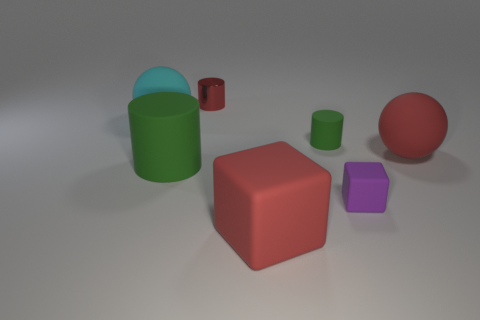Does the small shiny thing have the same color as the big block?
Your answer should be compact. Yes. What number of red things are made of the same material as the large red block?
Offer a terse response. 1. Are there any blocks left of the purple matte thing?
Provide a short and direct response. Yes. The matte ball that is the same size as the cyan matte thing is what color?
Your response must be concise. Red. What number of objects are either small purple blocks that are right of the big green cylinder or green things?
Provide a short and direct response. 3. What size is the object that is both on the right side of the small rubber cylinder and behind the purple object?
Offer a terse response. Large. There is a thing that is the same color as the big cylinder; what size is it?
Provide a short and direct response. Small. How many other things are the same size as the cyan ball?
Offer a very short reply. 3. There is a small rubber thing behind the big sphere to the right of the large ball behind the big red ball; what color is it?
Your answer should be very brief. Green. What shape is the large rubber thing that is behind the large green matte thing and on the left side of the small green cylinder?
Give a very brief answer. Sphere. 